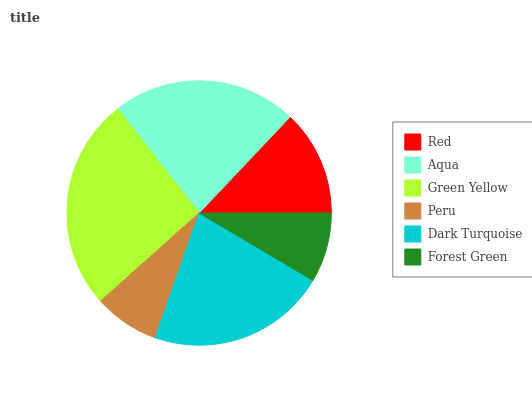Is Peru the minimum?
Answer yes or no. Yes. Is Green Yellow the maximum?
Answer yes or no. Yes. Is Aqua the minimum?
Answer yes or no. No. Is Aqua the maximum?
Answer yes or no. No. Is Aqua greater than Red?
Answer yes or no. Yes. Is Red less than Aqua?
Answer yes or no. Yes. Is Red greater than Aqua?
Answer yes or no. No. Is Aqua less than Red?
Answer yes or no. No. Is Dark Turquoise the high median?
Answer yes or no. Yes. Is Red the low median?
Answer yes or no. Yes. Is Peru the high median?
Answer yes or no. No. Is Green Yellow the low median?
Answer yes or no. No. 